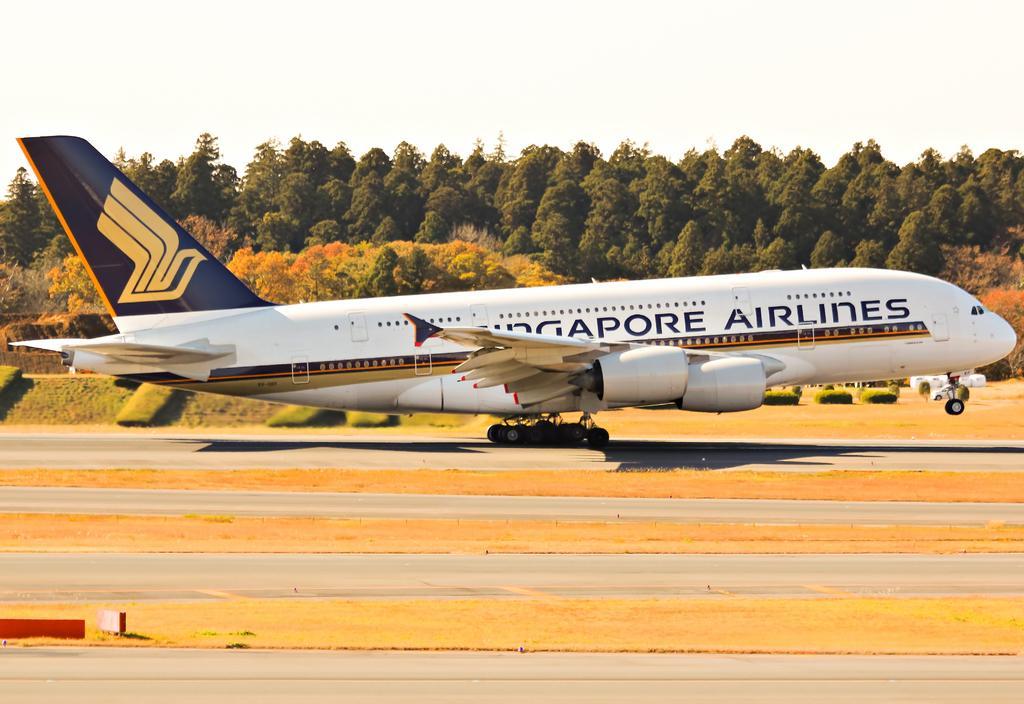How would you summarize this image in a sentence or two? This image consists of an airplane. At the bottom, there are roads. And we can see the grass on the ground. In the background, there are trees. At the top, there is sky. 